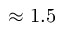<formula> <loc_0><loc_0><loc_500><loc_500>\approx 1 . 5</formula> 